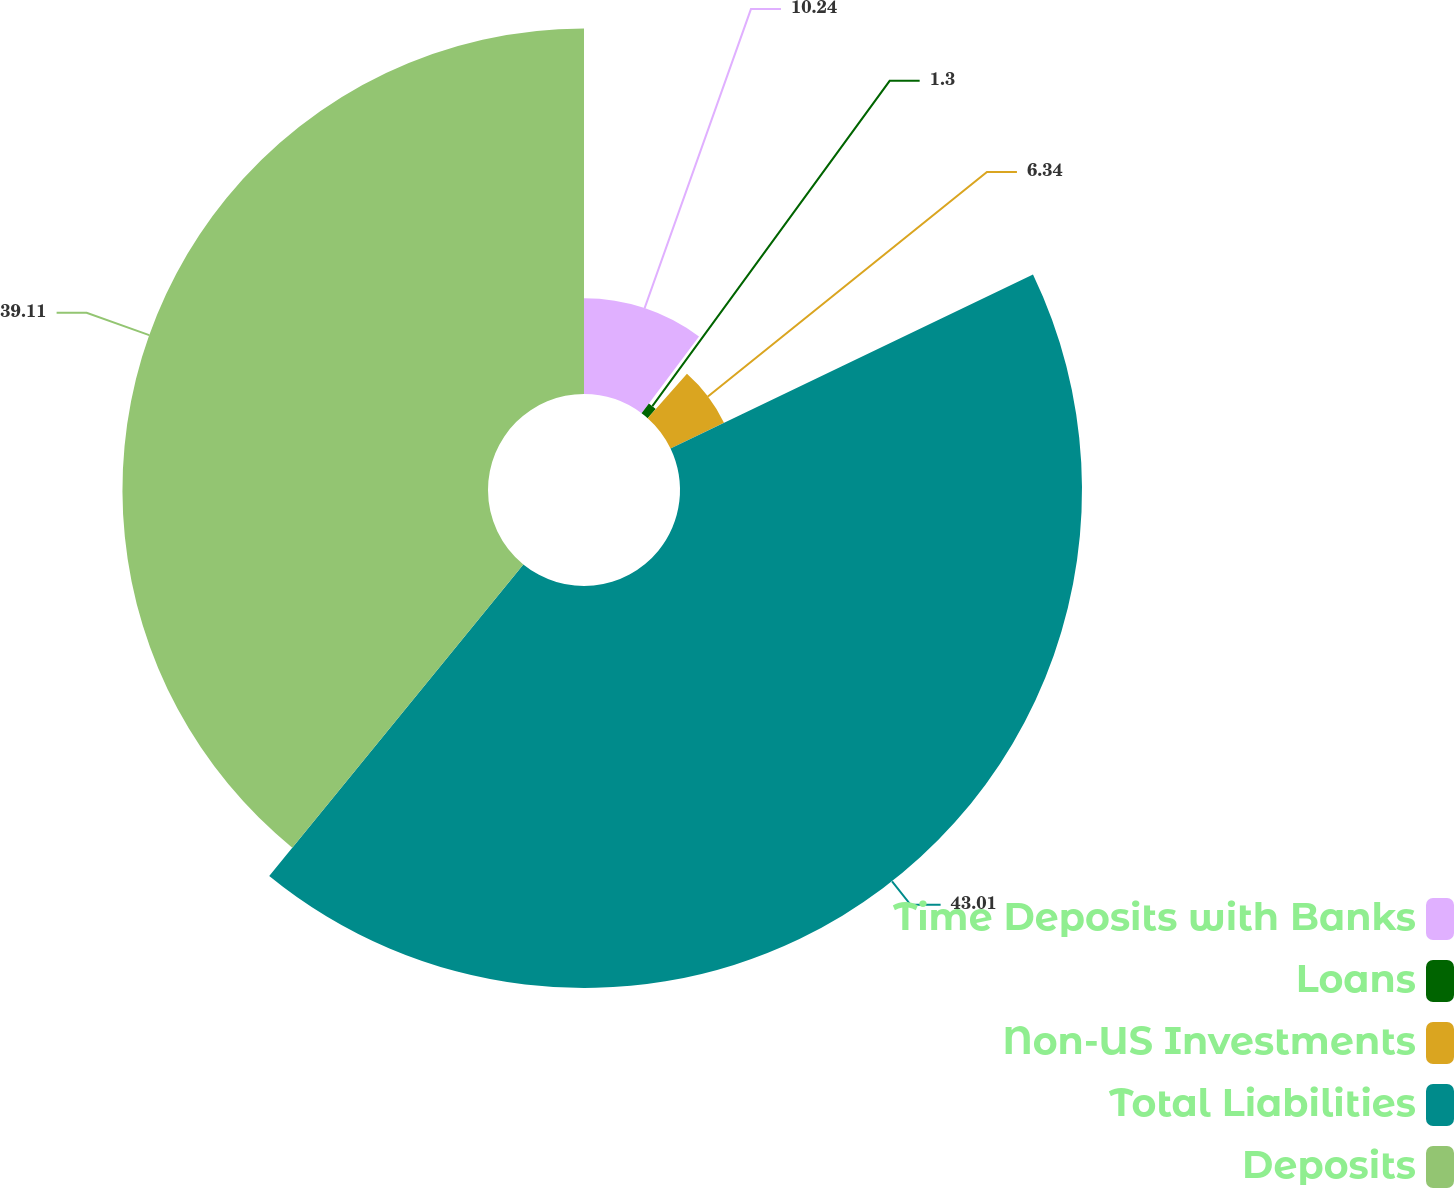<chart> <loc_0><loc_0><loc_500><loc_500><pie_chart><fcel>Time Deposits with Banks<fcel>Loans<fcel>Non-US Investments<fcel>Total Liabilities<fcel>Deposits<nl><fcel>10.24%<fcel>1.3%<fcel>6.34%<fcel>43.01%<fcel>39.11%<nl></chart> 